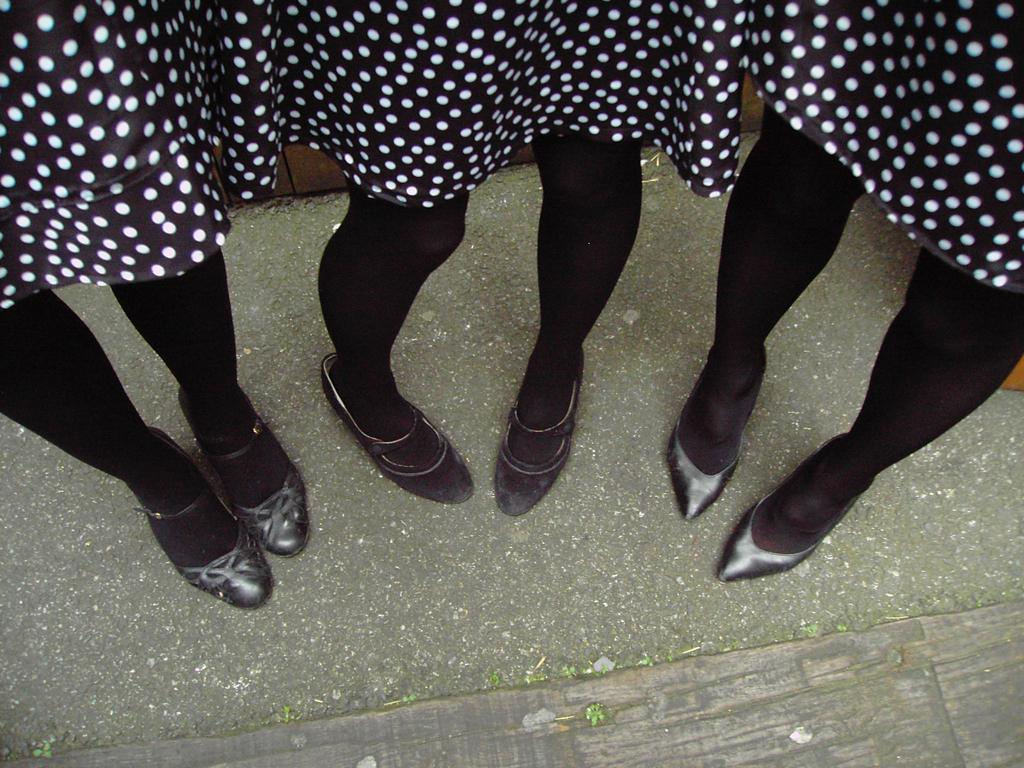How many people are in the image? There are three persons in the image. What are the persons doing in the image? The three persons are standing. What color are the socks worn by the persons in the image? The persons are wearing black color socks. What type of footwear are the persons wearing in the image? The persons are wearing black color shoes. What type of beast can be seen in the image? There is no beast present in the image; it features three standing persons. 